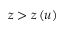Convert formula to latex. <formula><loc_0><loc_0><loc_500><loc_500>z > z \left ( u \right )</formula> 